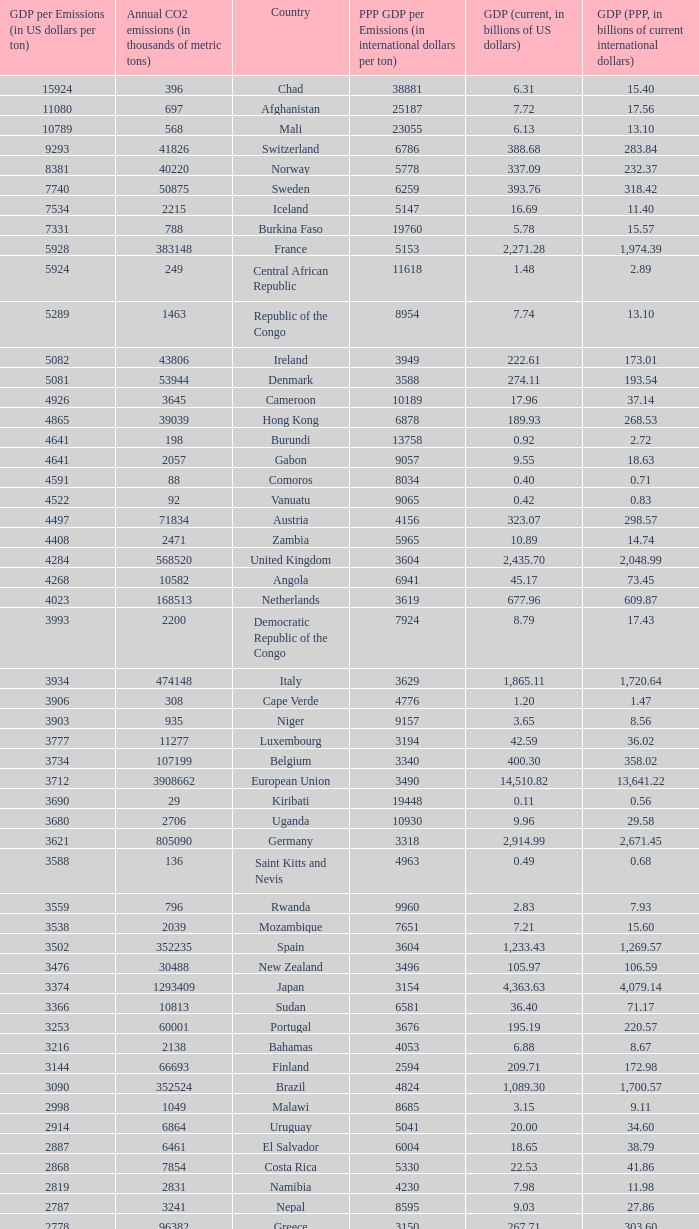When the gdp per emissions (in us dollars per ton) is 3903, what is the maximum annual co2 emissions (in thousands of metric tons)? 935.0. 